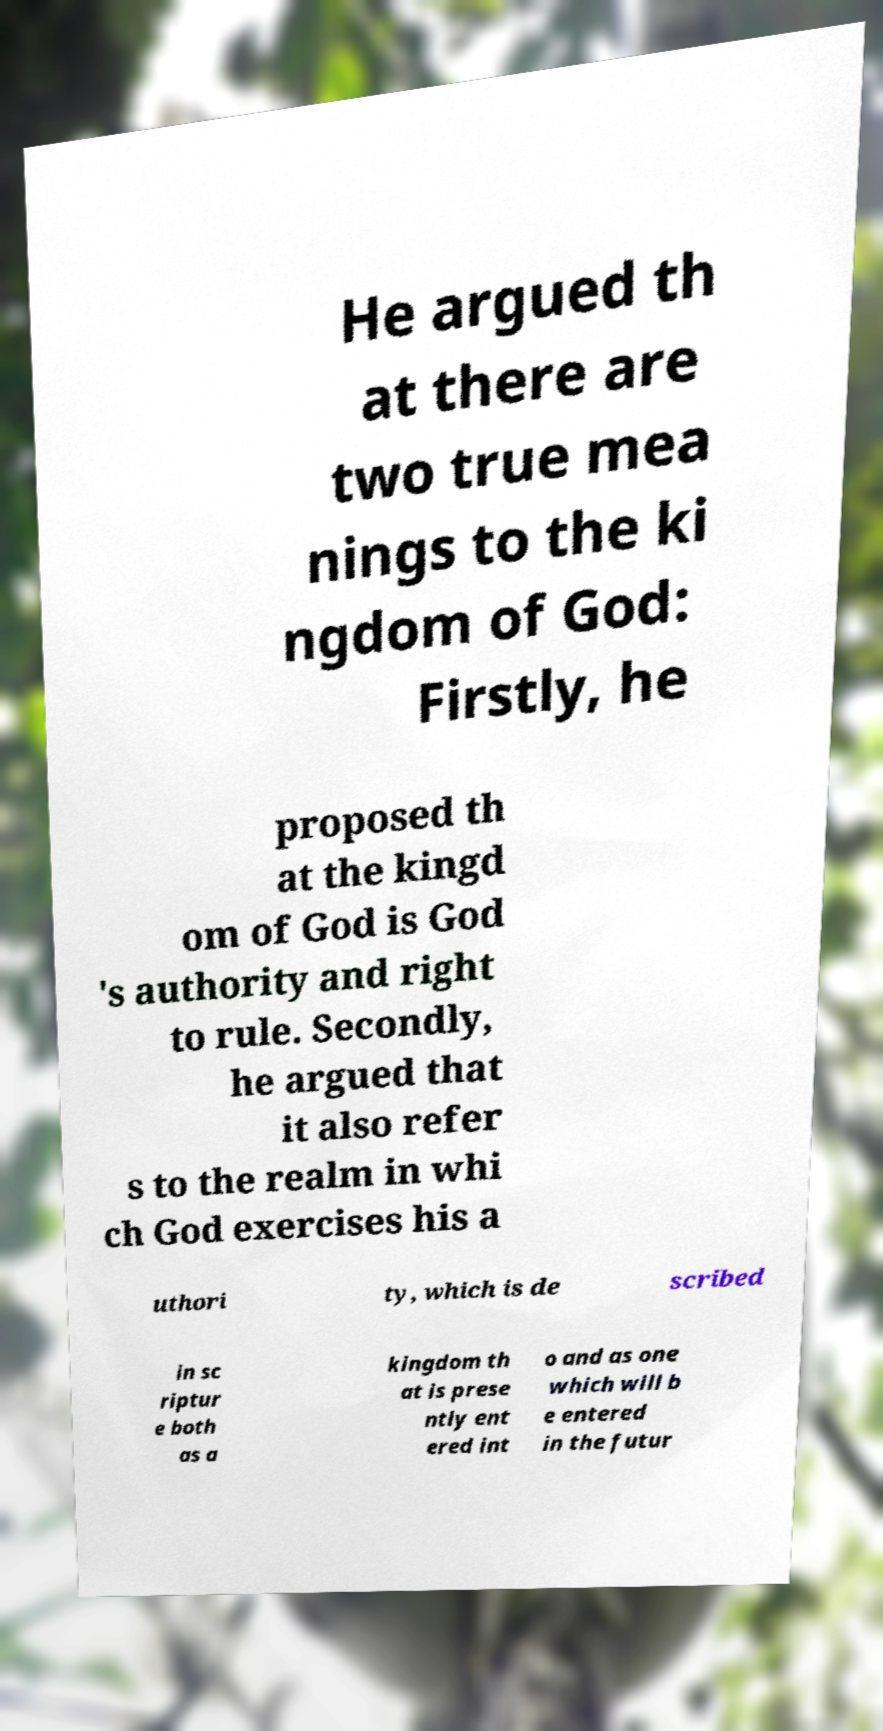Could you extract and type out the text from this image? He argued th at there are two true mea nings to the ki ngdom of God: Firstly, he proposed th at the kingd om of God is God 's authority and right to rule. Secondly, he argued that it also refer s to the realm in whi ch God exercises his a uthori ty, which is de scribed in sc riptur e both as a kingdom th at is prese ntly ent ered int o and as one which will b e entered in the futur 